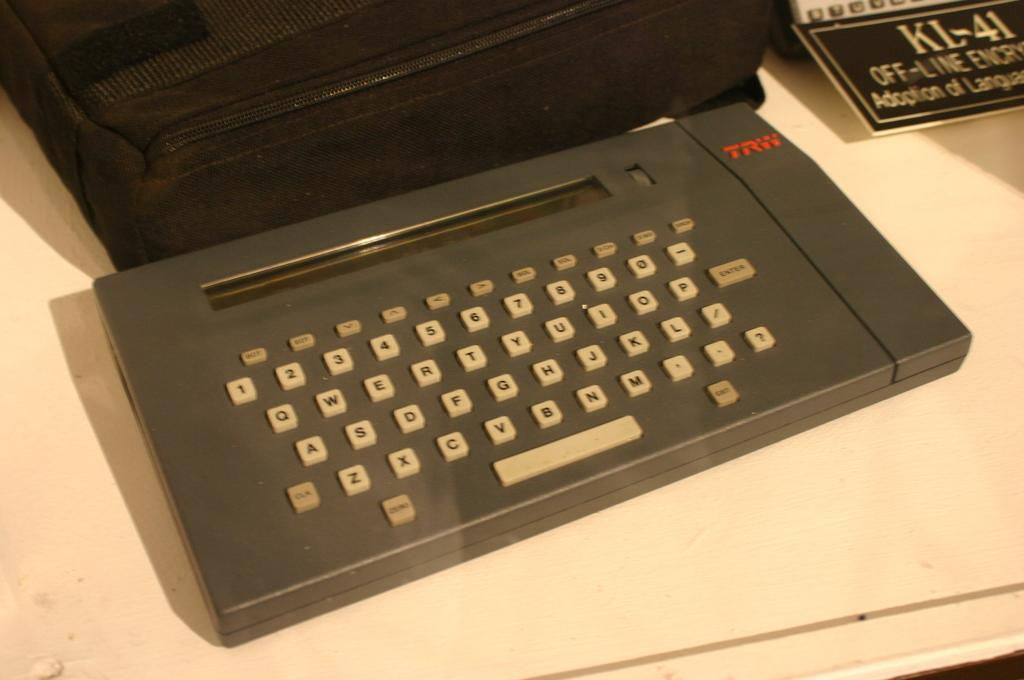Provide a one-sentence caption for the provided image. An old machine with a keyboard was made by TRW and now sits on a white table. 